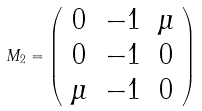Convert formula to latex. <formula><loc_0><loc_0><loc_500><loc_500>M _ { 2 } = \left ( \begin{array} { c c c } 0 & - 1 & \mu \\ 0 & - 1 & 0 \\ \mu & - 1 & 0 \end{array} \right )</formula> 